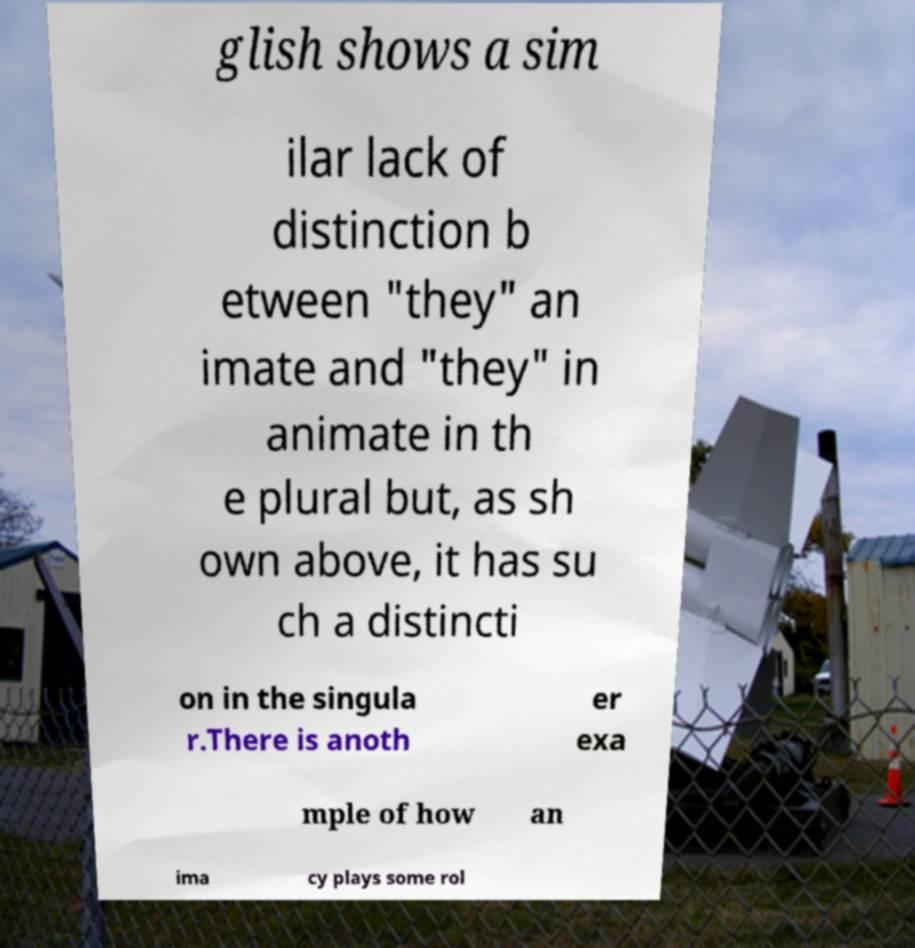Please read and relay the text visible in this image. What does it say? glish shows a sim ilar lack of distinction b etween "they" an imate and "they" in animate in th e plural but, as sh own above, it has su ch a distincti on in the singula r.There is anoth er exa mple of how an ima cy plays some rol 